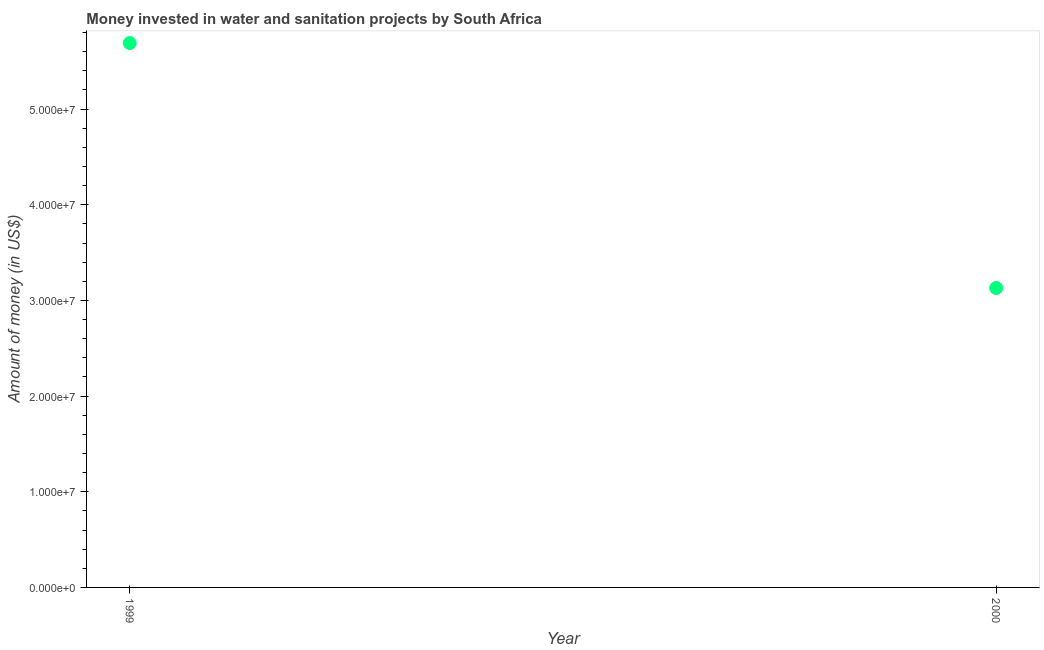What is the investment in 2000?
Offer a very short reply. 3.13e+07. Across all years, what is the maximum investment?
Provide a short and direct response. 5.69e+07. Across all years, what is the minimum investment?
Ensure brevity in your answer.  3.13e+07. In which year was the investment maximum?
Keep it short and to the point. 1999. What is the sum of the investment?
Give a very brief answer. 8.82e+07. What is the difference between the investment in 1999 and 2000?
Your response must be concise. 2.56e+07. What is the average investment per year?
Ensure brevity in your answer.  4.41e+07. What is the median investment?
Offer a terse response. 4.41e+07. What is the ratio of the investment in 1999 to that in 2000?
Provide a succinct answer. 1.82. Is the investment in 1999 less than that in 2000?
Your answer should be compact. No. How many years are there in the graph?
Make the answer very short. 2. Are the values on the major ticks of Y-axis written in scientific E-notation?
Provide a short and direct response. Yes. Does the graph contain any zero values?
Provide a succinct answer. No. Does the graph contain grids?
Your answer should be very brief. No. What is the title of the graph?
Provide a short and direct response. Money invested in water and sanitation projects by South Africa. What is the label or title of the Y-axis?
Provide a succinct answer. Amount of money (in US$). What is the Amount of money (in US$) in 1999?
Provide a succinct answer. 5.69e+07. What is the Amount of money (in US$) in 2000?
Keep it short and to the point. 3.13e+07. What is the difference between the Amount of money (in US$) in 1999 and 2000?
Your answer should be very brief. 2.56e+07. What is the ratio of the Amount of money (in US$) in 1999 to that in 2000?
Offer a terse response. 1.82. 